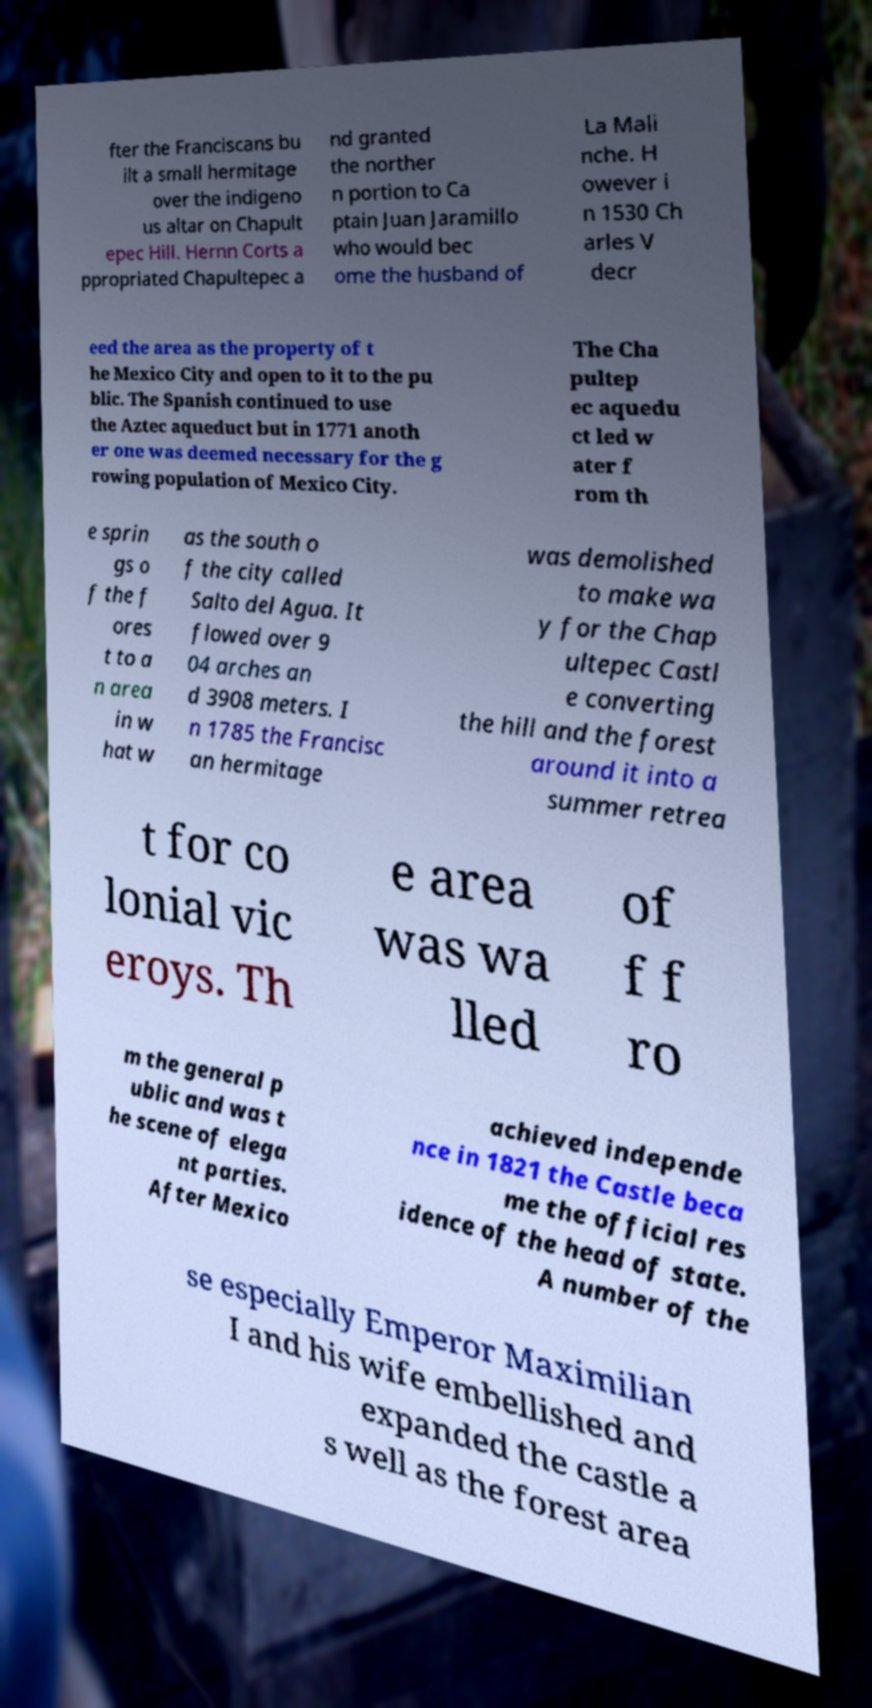There's text embedded in this image that I need extracted. Can you transcribe it verbatim? fter the Franciscans bu ilt a small hermitage over the indigeno us altar on Chapult epec Hill. Hernn Corts a ppropriated Chapultepec a nd granted the norther n portion to Ca ptain Juan Jaramillo who would bec ome the husband of La Mali nche. H owever i n 1530 Ch arles V decr eed the area as the property of t he Mexico City and open to it to the pu blic. The Spanish continued to use the Aztec aqueduct but in 1771 anoth er one was deemed necessary for the g rowing population of Mexico City. The Cha pultep ec aquedu ct led w ater f rom th e sprin gs o f the f ores t to a n area in w hat w as the south o f the city called Salto del Agua. It flowed over 9 04 arches an d 3908 meters. I n 1785 the Francisc an hermitage was demolished to make wa y for the Chap ultepec Castl e converting the hill and the forest around it into a summer retrea t for co lonial vic eroys. Th e area was wa lled of f f ro m the general p ublic and was t he scene of elega nt parties. After Mexico achieved independe nce in 1821 the Castle beca me the official res idence of the head of state. A number of the se especially Emperor Maximilian I and his wife embellished and expanded the castle a s well as the forest area 